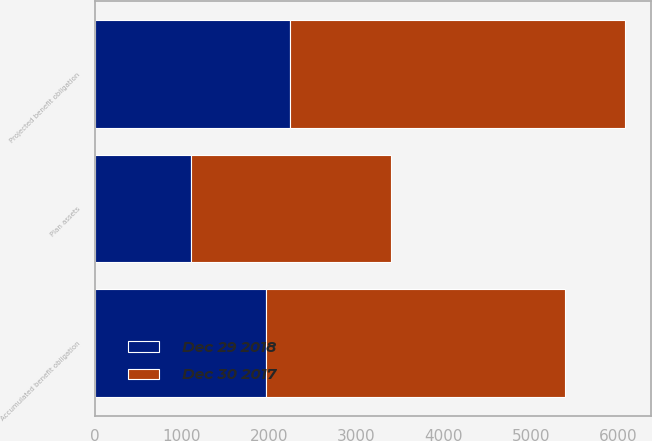Convert chart to OTSL. <chart><loc_0><loc_0><loc_500><loc_500><stacked_bar_chart><ecel><fcel>Accumulated benefit obligation<fcel>Plan assets<fcel>Projected benefit obligation<nl><fcel>Dec 29 2018<fcel>1965<fcel>1106<fcel>2232<nl><fcel>Dec 30 2017<fcel>3423<fcel>2287<fcel>3842<nl></chart> 